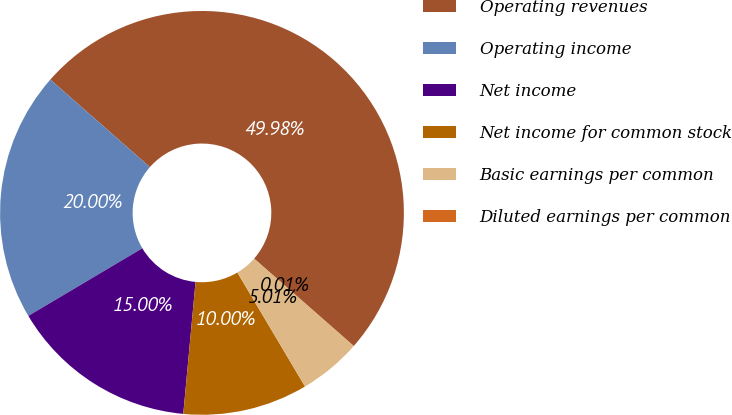<chart> <loc_0><loc_0><loc_500><loc_500><pie_chart><fcel>Operating revenues<fcel>Operating income<fcel>Net income<fcel>Net income for common stock<fcel>Basic earnings per common<fcel>Diluted earnings per common<nl><fcel>49.98%<fcel>20.0%<fcel>15.0%<fcel>10.0%<fcel>5.01%<fcel>0.01%<nl></chart> 